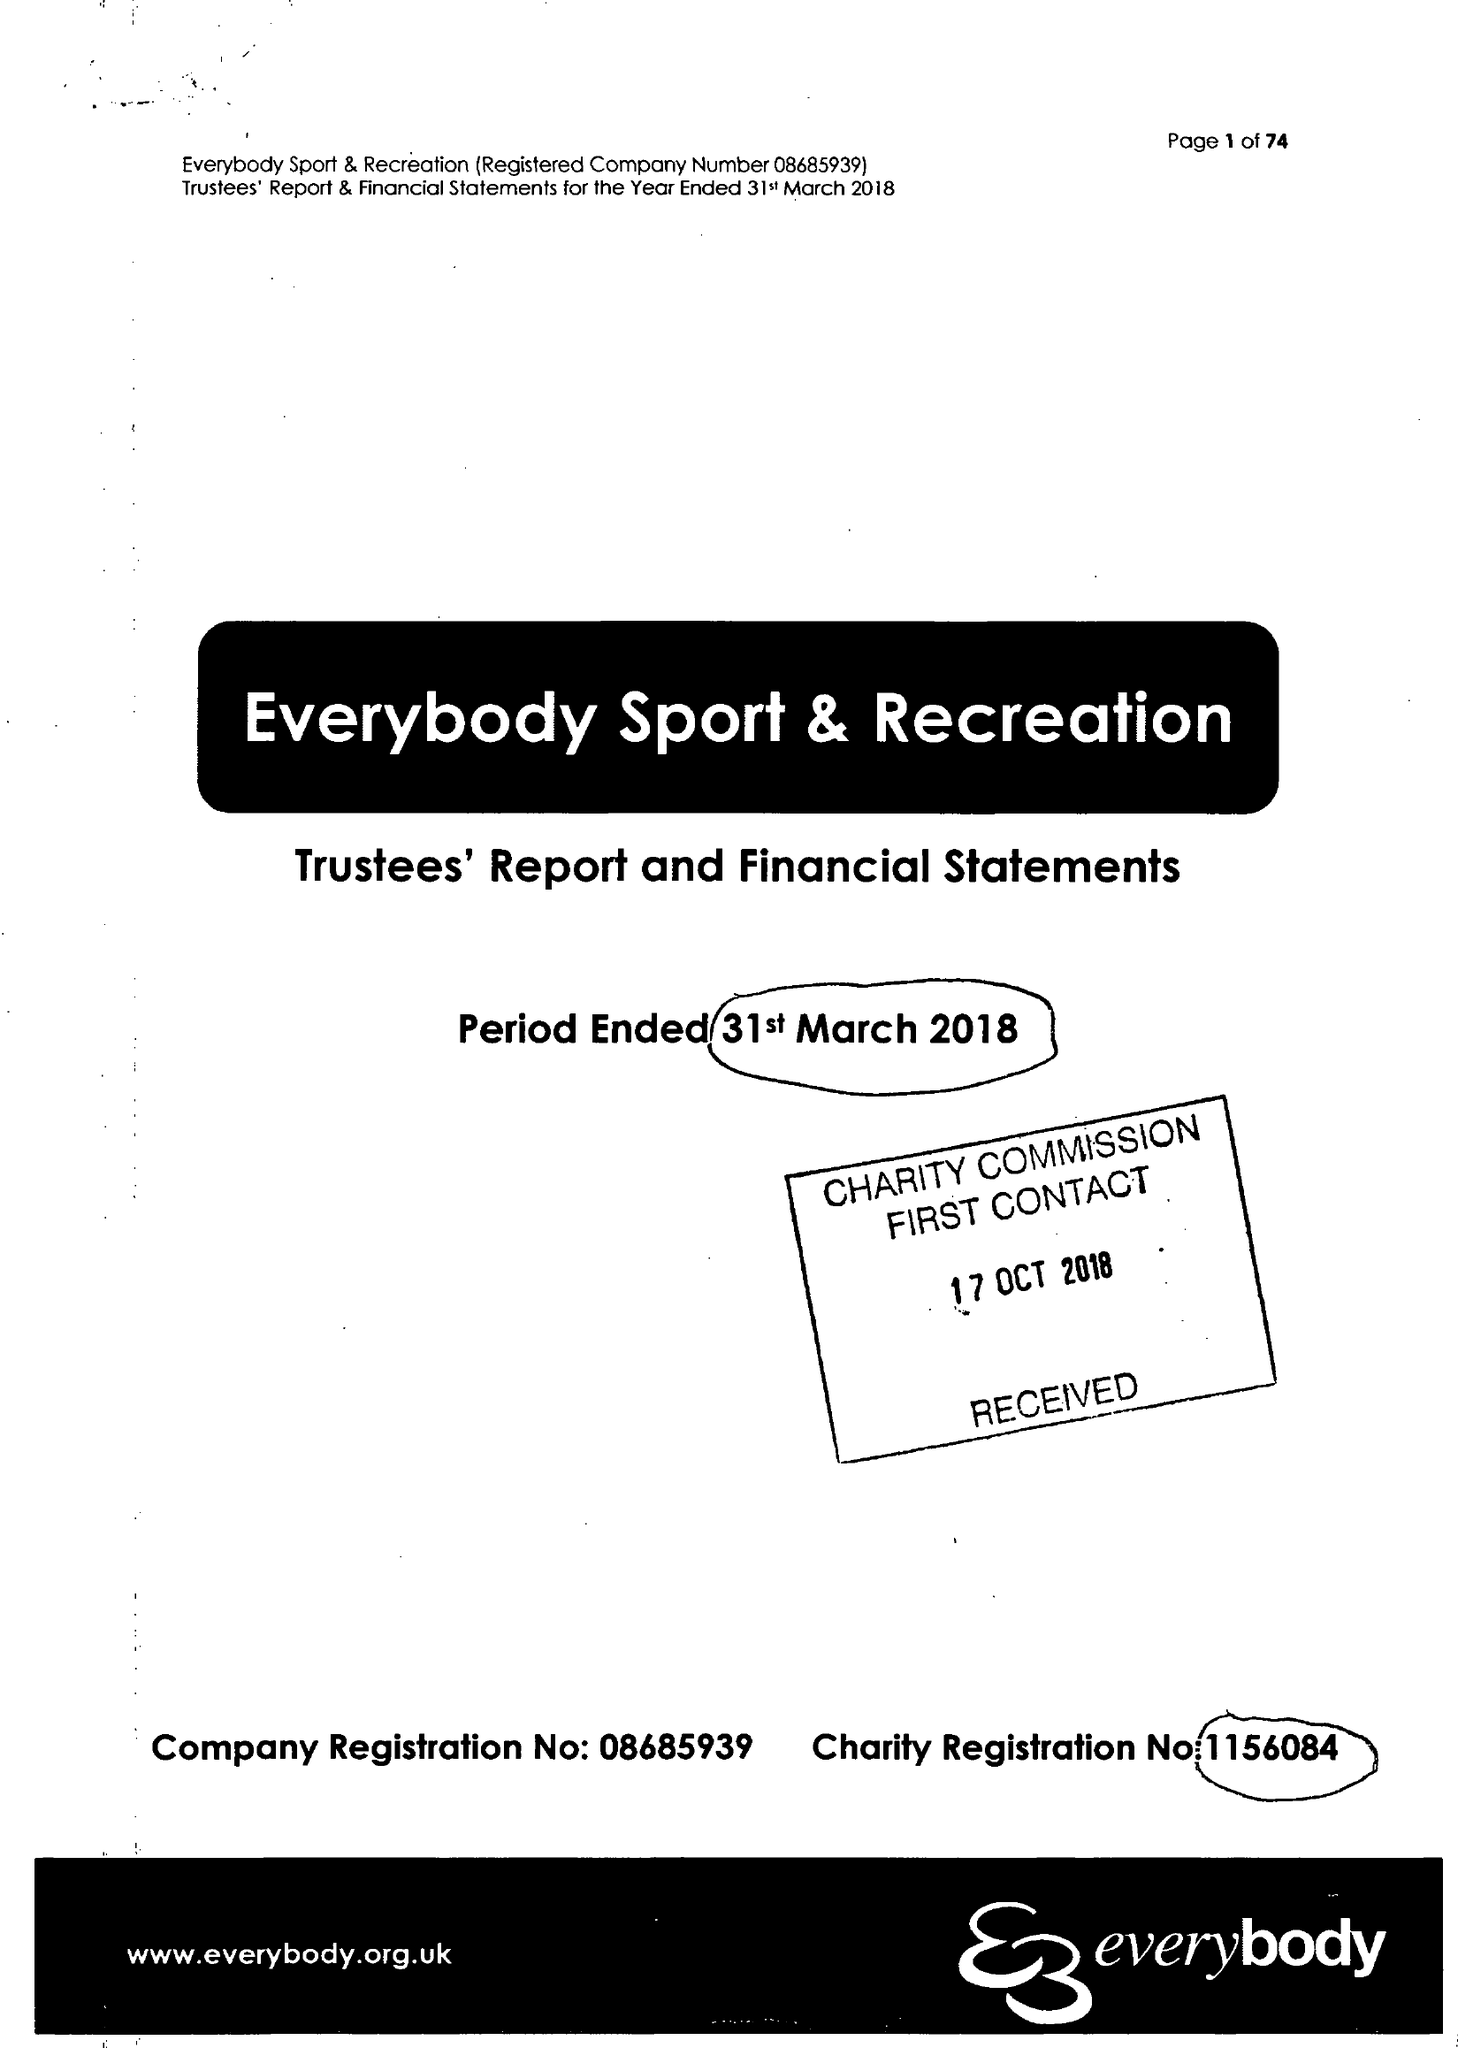What is the value for the address__post_town?
Answer the question using a single word or phrase. CREWE 